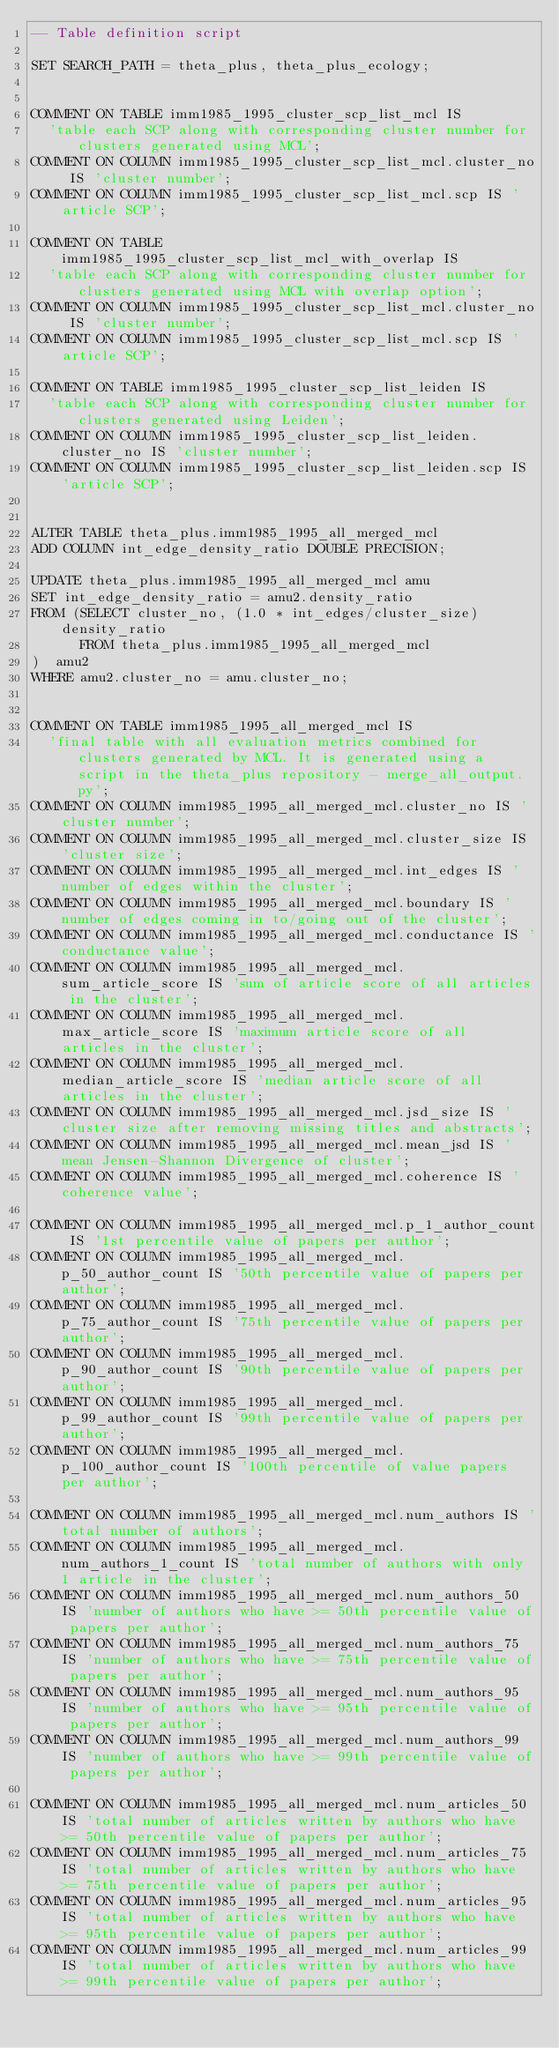<code> <loc_0><loc_0><loc_500><loc_500><_SQL_>-- Table definition script

SET SEARCH_PATH = theta_plus, theta_plus_ecology;


COMMENT ON TABLE imm1985_1995_cluster_scp_list_mcl IS
  'table each SCP along with corresponding cluster number for clusters generated using MCL';
COMMENT ON COLUMN imm1985_1995_cluster_scp_list_mcl.cluster_no IS 'cluster number';
COMMENT ON COLUMN imm1985_1995_cluster_scp_list_mcl.scp IS 'article SCP';

COMMENT ON TABLE imm1985_1995_cluster_scp_list_mcl_with_overlap IS
  'table each SCP along with corresponding cluster number for clusters generated using MCL with overlap option';
COMMENT ON COLUMN imm1985_1995_cluster_scp_list_mcl.cluster_no IS 'cluster number';
COMMENT ON COLUMN imm1985_1995_cluster_scp_list_mcl.scp IS 'article SCP';

COMMENT ON TABLE imm1985_1995_cluster_scp_list_leiden IS
  'table each SCP along with corresponding cluster number for clusters generated using Leiden';
COMMENT ON COLUMN imm1985_1995_cluster_scp_list_leiden.cluster_no IS 'cluster number';
COMMENT ON COLUMN imm1985_1995_cluster_scp_list_leiden.scp IS 'article SCP';


ALTER TABLE theta_plus.imm1985_1995_all_merged_mcl
ADD COLUMN int_edge_density_ratio DOUBLE PRECISION;

UPDATE theta_plus.imm1985_1995_all_merged_mcl amu
SET int_edge_density_ratio = amu2.density_ratio
FROM (SELECT cluster_no, (1.0 * int_edges/cluster_size) density_ratio
      FROM theta_plus.imm1985_1995_all_merged_mcl
)  amu2
WHERE amu2.cluster_no = amu.cluster_no;


COMMENT ON TABLE imm1985_1995_all_merged_mcl IS
  'final table with all evaluation metrics combined for clusters generated by MCL. It is generated using a script in the theta_plus repository - merge_all_output.py';
COMMENT ON COLUMN imm1985_1995_all_merged_mcl.cluster_no IS 'cluster number';
COMMENT ON COLUMN imm1985_1995_all_merged_mcl.cluster_size IS 'cluster size';
COMMENT ON COLUMN imm1985_1995_all_merged_mcl.int_edges IS 'number of edges within the cluster';
COMMENT ON COLUMN imm1985_1995_all_merged_mcl.boundary IS 'number of edges coming in to/going out of the cluster';
COMMENT ON COLUMN imm1985_1995_all_merged_mcl.conductance IS 'conductance value';
COMMENT ON COLUMN imm1985_1995_all_merged_mcl.sum_article_score IS 'sum of article score of all articles in the cluster';
COMMENT ON COLUMN imm1985_1995_all_merged_mcl.max_article_score IS 'maximum article score of all articles in the cluster';
COMMENT ON COLUMN imm1985_1995_all_merged_mcl.median_article_score IS 'median article score of all articles in the cluster';
COMMENT ON COLUMN imm1985_1995_all_merged_mcl.jsd_size IS 'cluster size after removing missing titles and abstracts';
COMMENT ON COLUMN imm1985_1995_all_merged_mcl.mean_jsd IS 'mean Jensen-Shannon Divergence of cluster';
COMMENT ON COLUMN imm1985_1995_all_merged_mcl.coherence IS 'coherence value';

COMMENT ON COLUMN imm1985_1995_all_merged_mcl.p_1_author_count IS '1st percentile value of papers per author';
COMMENT ON COLUMN imm1985_1995_all_merged_mcl.p_50_author_count IS '50th percentile value of papers per author';
COMMENT ON COLUMN imm1985_1995_all_merged_mcl.p_75_author_count IS '75th percentile value of papers per author';
COMMENT ON COLUMN imm1985_1995_all_merged_mcl.p_90_author_count IS '90th percentile value of papers per author';
COMMENT ON COLUMN imm1985_1995_all_merged_mcl.p_99_author_count IS '99th percentile value of papers per author';
COMMENT ON COLUMN imm1985_1995_all_merged_mcl.p_100_author_count IS '100th percentile of value papers per author';

COMMENT ON COLUMN imm1985_1995_all_merged_mcl.num_authors IS 'total number of authors';
COMMENT ON COLUMN imm1985_1995_all_merged_mcl.num_authors_1_count IS 'total number of authors with only 1 article in the cluster';
COMMENT ON COLUMN imm1985_1995_all_merged_mcl.num_authors_50 IS 'number of authors who have >= 50th percentile value of papers per author';
COMMENT ON COLUMN imm1985_1995_all_merged_mcl.num_authors_75 IS 'number of authors who have >= 75th percentile value of papers per author';
COMMENT ON COLUMN imm1985_1995_all_merged_mcl.num_authors_95 IS 'number of authors who have >= 95th percentile value of papers per author';
COMMENT ON COLUMN imm1985_1995_all_merged_mcl.num_authors_99 IS 'number of authors who have >= 99th percentile value of papers per author';

COMMENT ON COLUMN imm1985_1995_all_merged_mcl.num_articles_50 IS 'total number of articles written by authors who have >= 50th percentile value of papers per author';
COMMENT ON COLUMN imm1985_1995_all_merged_mcl.num_articles_75 IS 'total number of articles written by authors who have >= 75th percentile value of papers per author';
COMMENT ON COLUMN imm1985_1995_all_merged_mcl.num_articles_95 IS 'total number of articles written by authors who have >= 95th percentile value of papers per author';
COMMENT ON COLUMN imm1985_1995_all_merged_mcl.num_articles_99 IS 'total number of articles written by authors who have >= 99th percentile value of papers per author';
</code> 